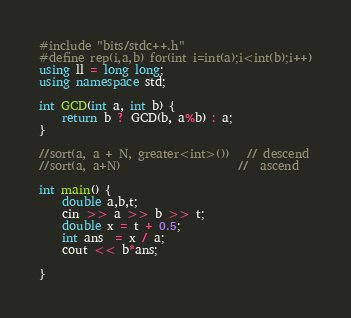Convert code to text. <code><loc_0><loc_0><loc_500><loc_500><_C++_>#include "bits/stdc++.h"
#define rep(i,a,b) for(int i=int(a);i<int(b);i++)
using ll = long long;
using namespace std;

int GCD(int a, int b) {
	return b ? GCD(b, a%b) : a;
}

//sort(a, a + N, greater<int>())   // descend
//sort(a, a+N)                    //  ascend

int main() {
	double a,b,t;
	cin >> a >> b >> t;
	double x = t + 0.5;
	int ans  = x / a;
	cout << b*ans;
	
}
</code> 